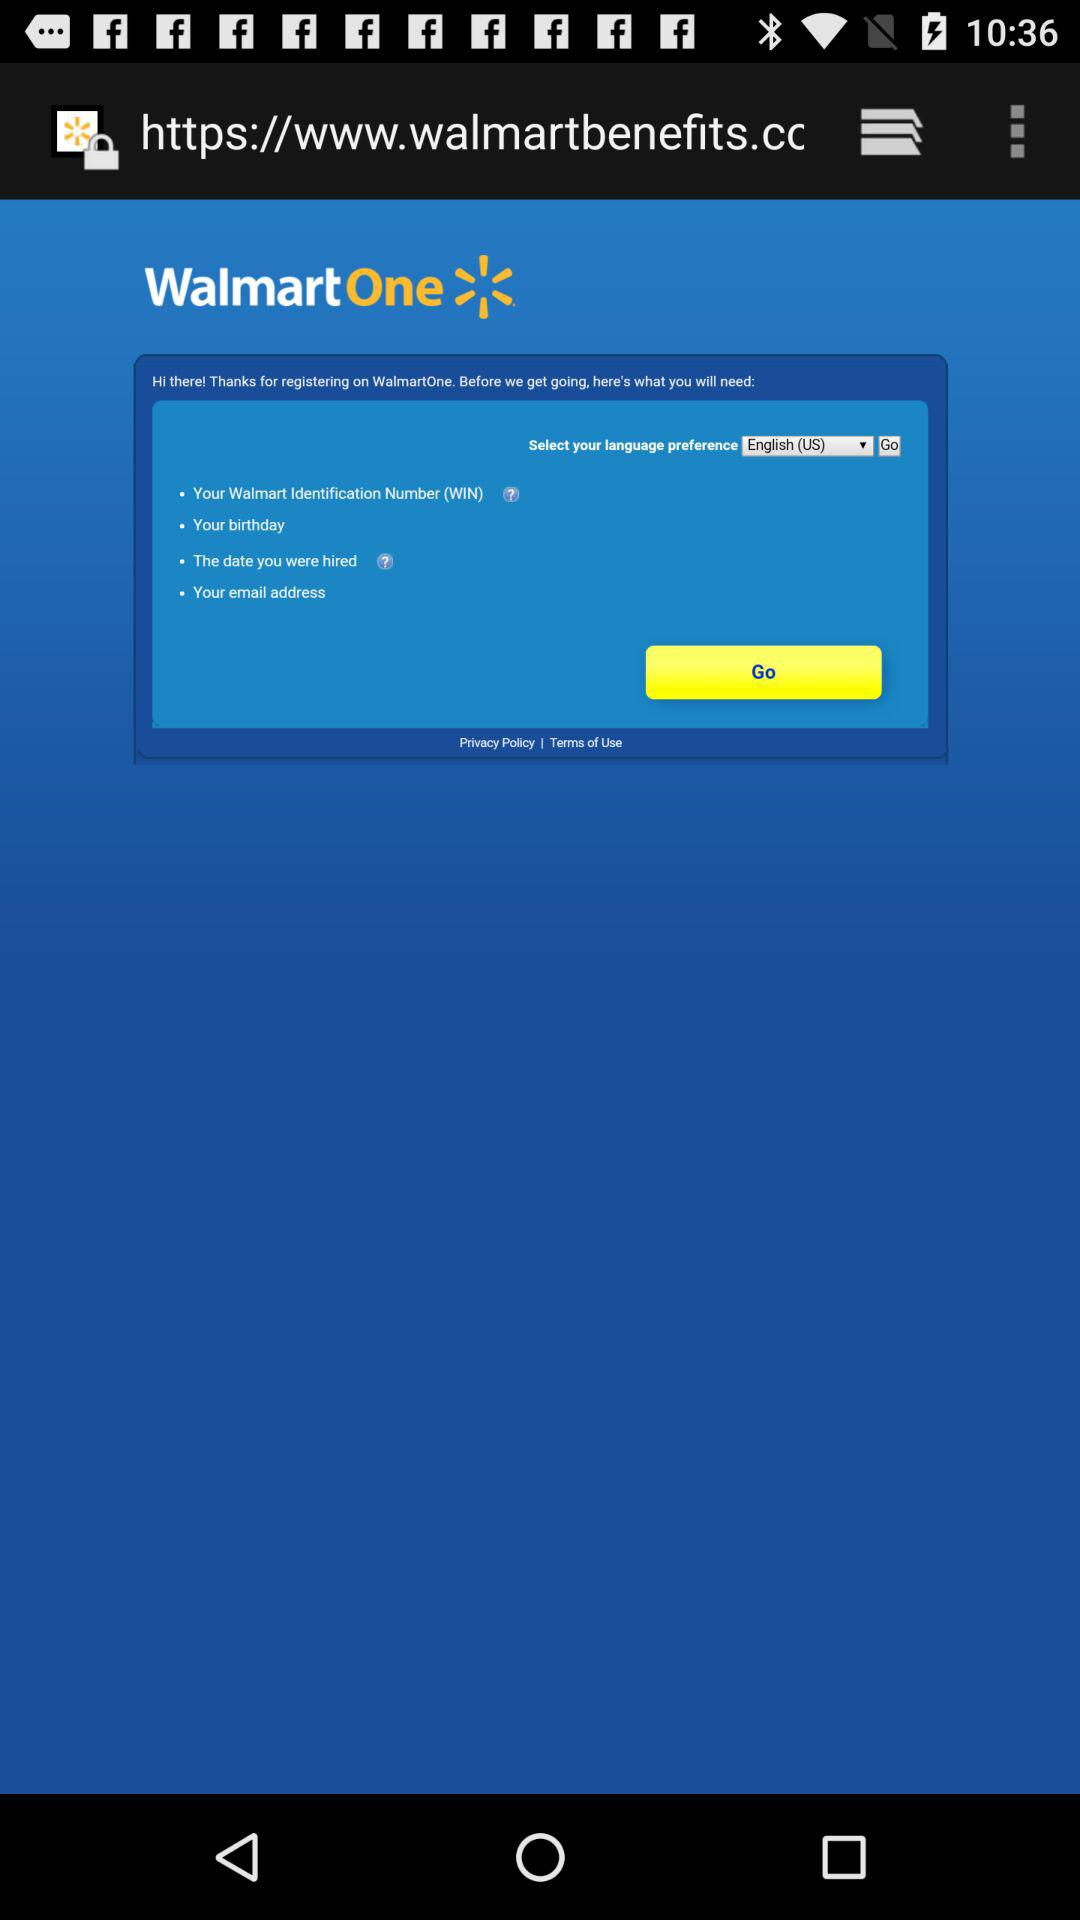What is the name of the application? The name of the application is "WalmartOne". 